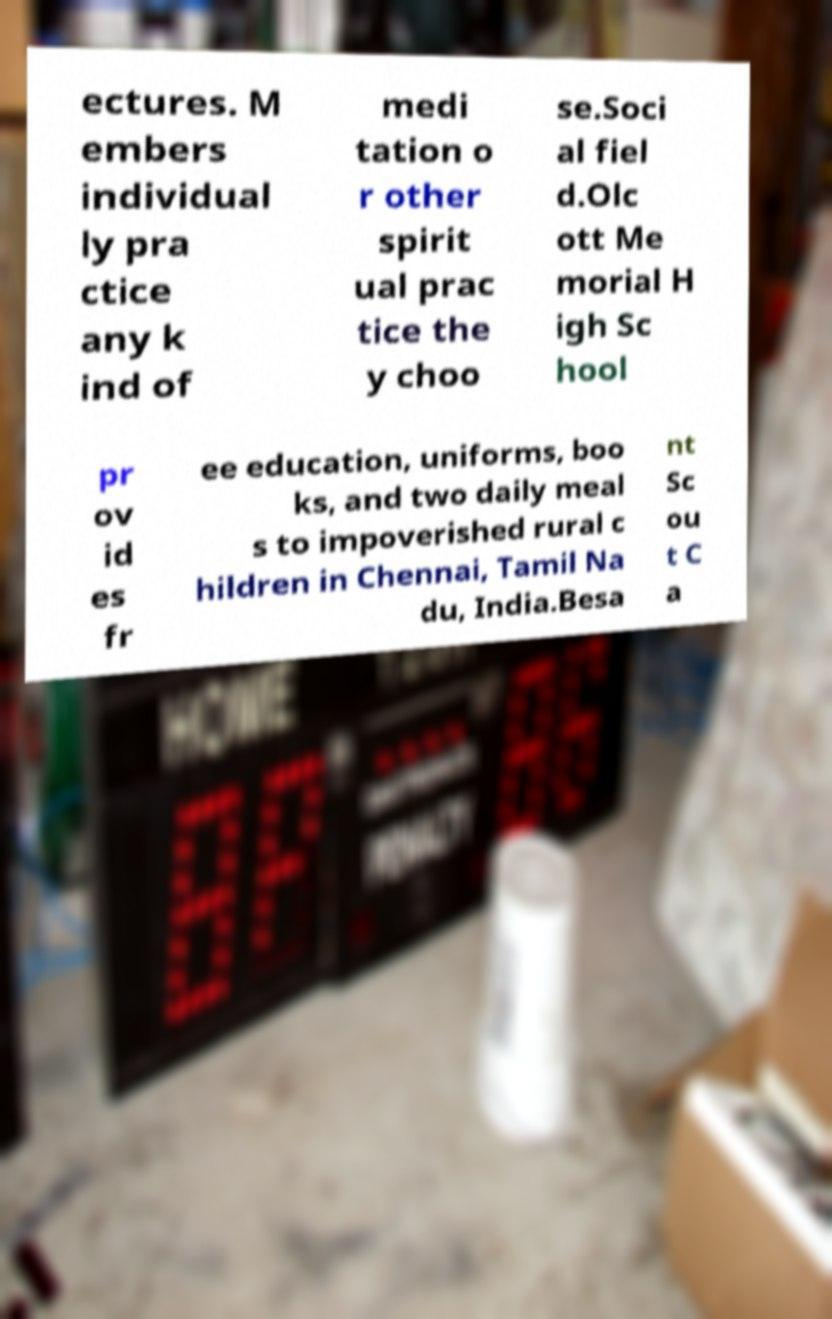Could you assist in decoding the text presented in this image and type it out clearly? ectures. M embers individual ly pra ctice any k ind of medi tation o r other spirit ual prac tice the y choo se.Soci al fiel d.Olc ott Me morial H igh Sc hool pr ov id es fr ee education, uniforms, boo ks, and two daily meal s to impoverished rural c hildren in Chennai, Tamil Na du, India.Besa nt Sc ou t C a 